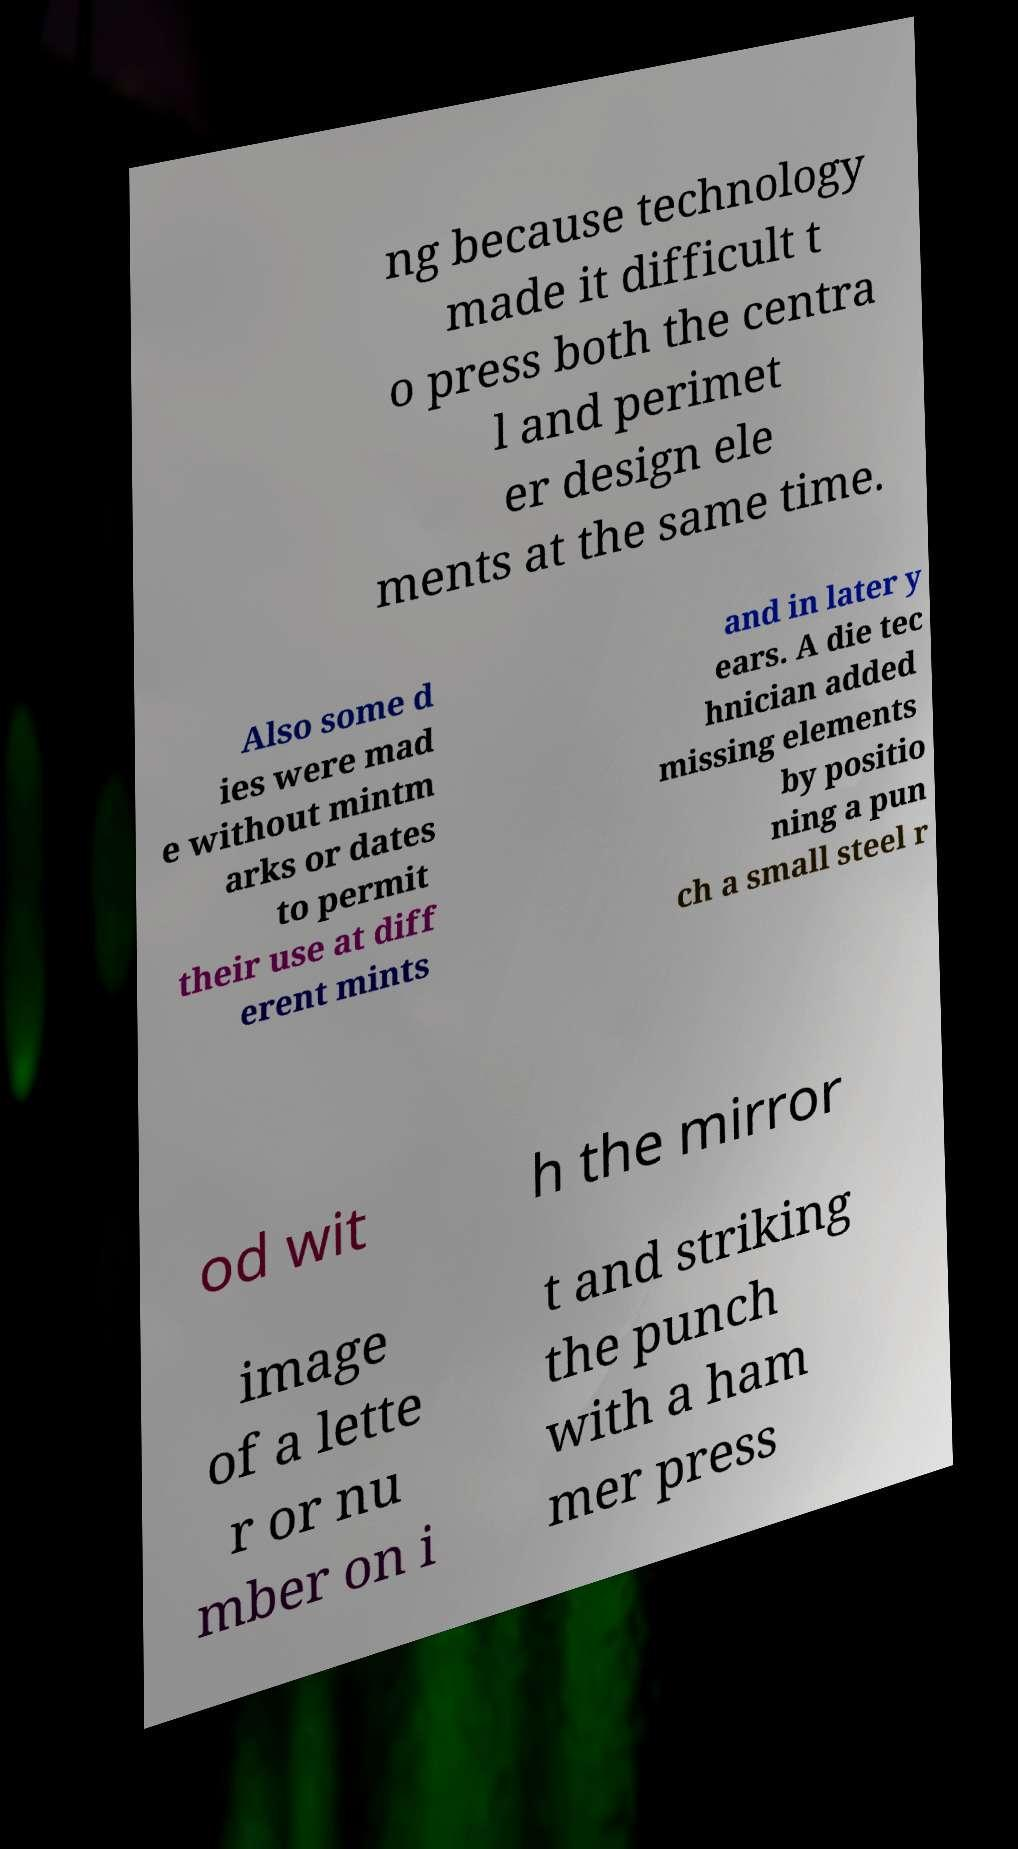For documentation purposes, I need the text within this image transcribed. Could you provide that? ng because technology made it difficult t o press both the centra l and perimet er design ele ments at the same time. Also some d ies were mad e without mintm arks or dates to permit their use at diff erent mints and in later y ears. A die tec hnician added missing elements by positio ning a pun ch a small steel r od wit h the mirror image of a lette r or nu mber on i t and striking the punch with a ham mer press 